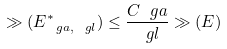Convert formula to latex. <formula><loc_0><loc_0><loc_500><loc_500>\gg ( E _ { \ g a , \ g l } ^ { * } ) \leq \frac { C _ { \ } g a } { \ g l } \gg ( E )</formula> 